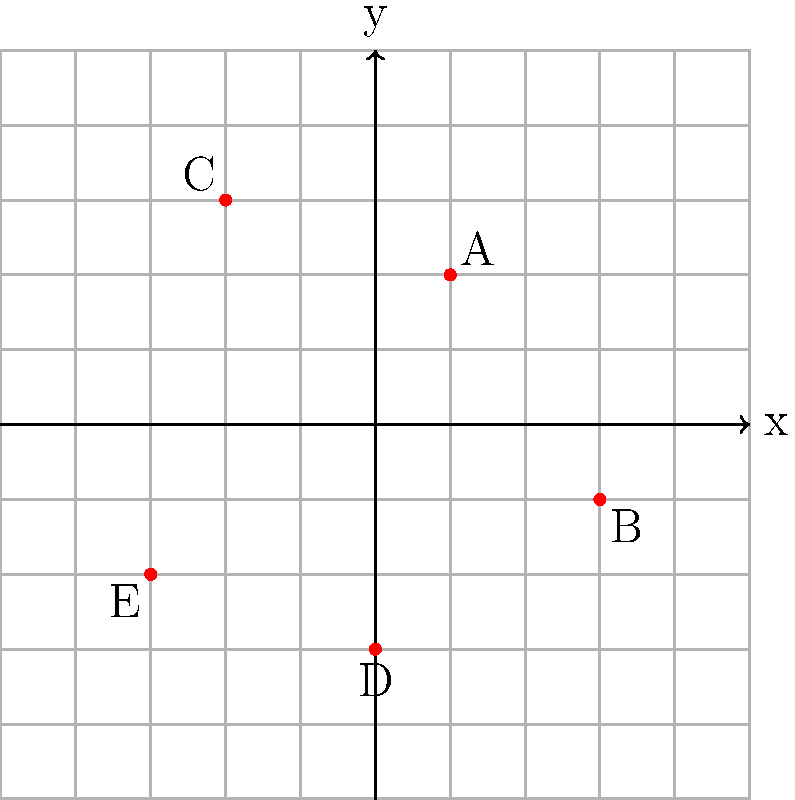As the executive in charge of optimizing office space, you've plotted the preferred desk locations of five key employees on a coordinate plane. Employee A is at (1,2), B at (3,-1), C at (-2,3), D at (0,-3), and E at (-3,-2). To minimize inter-office travel time, you need to find the location for a central meeting area. What are the coordinates of the point that minimizes the sum of the distances from all employees to this central point? To solve this problem, we need to find the centroid of the given points, which represents the arithmetic mean position of all the points in the set. This is an optimal solution for minimizing the sum of distances.

Step 1: Calculate the average x-coordinate:
$$x_{avg} = \frac{1 + 3 + (-2) + 0 + (-3)}{5} = -0.2$$

Step 2: Calculate the average y-coordinate:
$$y_{avg} = \frac{2 + (-1) + 3 + (-3) + (-2)}{5} = -0.2$$

Step 3: The centroid is the point (x_avg, y_avg), which in this case is (-0.2, -0.2).

This point (-0.2, -0.2) represents the optimal location for the central meeting area as it minimizes the sum of distances from all employees to this central point.

As an executive who excels at connecting with people, this solution not only optimizes the physical space but also creates an equitable arrangement that considers each employee's preference, potentially boosting morale and collaboration.
Answer: (-0.2, -0.2) 